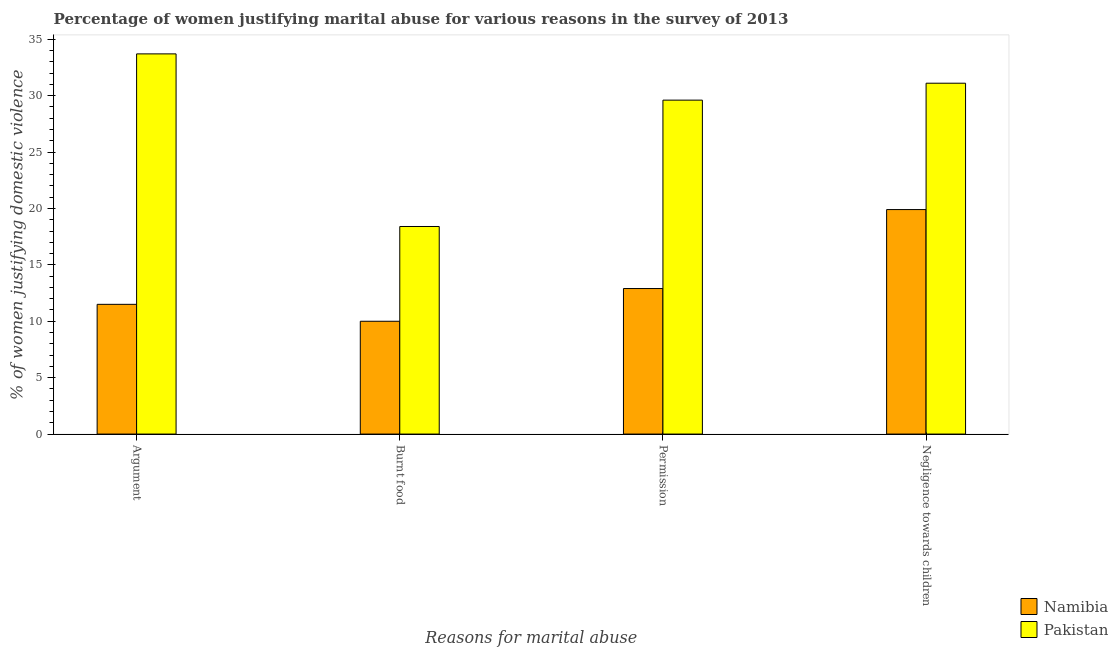How many different coloured bars are there?
Offer a terse response. 2. How many groups of bars are there?
Give a very brief answer. 4. How many bars are there on the 2nd tick from the right?
Your answer should be very brief. 2. What is the label of the 1st group of bars from the left?
Your answer should be compact. Argument. What is the percentage of women justifying abuse for burning food in Namibia?
Ensure brevity in your answer.  10. Across all countries, what is the maximum percentage of women justifying abuse for going without permission?
Your response must be concise. 29.6. Across all countries, what is the minimum percentage of women justifying abuse for burning food?
Offer a terse response. 10. In which country was the percentage of women justifying abuse for burning food maximum?
Ensure brevity in your answer.  Pakistan. In which country was the percentage of women justifying abuse in the case of an argument minimum?
Give a very brief answer. Namibia. What is the total percentage of women justifying abuse for burning food in the graph?
Offer a very short reply. 28.4. What is the difference between the percentage of women justifying abuse for showing negligence towards children in Namibia and that in Pakistan?
Provide a succinct answer. -11.2. What is the difference between the percentage of women justifying abuse for burning food in Namibia and the percentage of women justifying abuse in the case of an argument in Pakistan?
Keep it short and to the point. -23.7. What is the average percentage of women justifying abuse for showing negligence towards children per country?
Your answer should be compact. 25.5. What is the difference between the percentage of women justifying abuse in the case of an argument and percentage of women justifying abuse for going without permission in Pakistan?
Keep it short and to the point. 4.1. What is the ratio of the percentage of women justifying abuse for burning food in Pakistan to that in Namibia?
Give a very brief answer. 1.84. Is the difference between the percentage of women justifying abuse for going without permission in Pakistan and Namibia greater than the difference between the percentage of women justifying abuse for showing negligence towards children in Pakistan and Namibia?
Ensure brevity in your answer.  Yes. What is the difference between the highest and the second highest percentage of women justifying abuse for burning food?
Your answer should be compact. 8.4. What is the difference between the highest and the lowest percentage of women justifying abuse for going without permission?
Make the answer very short. 16.7. In how many countries, is the percentage of women justifying abuse in the case of an argument greater than the average percentage of women justifying abuse in the case of an argument taken over all countries?
Keep it short and to the point. 1. Is the sum of the percentage of women justifying abuse for going without permission in Pakistan and Namibia greater than the maximum percentage of women justifying abuse for showing negligence towards children across all countries?
Keep it short and to the point. Yes. What does the 1st bar from the left in Argument represents?
Give a very brief answer. Namibia. What does the 2nd bar from the right in Negligence towards children represents?
Your answer should be very brief. Namibia. Is it the case that in every country, the sum of the percentage of women justifying abuse in the case of an argument and percentage of women justifying abuse for burning food is greater than the percentage of women justifying abuse for going without permission?
Ensure brevity in your answer.  Yes. How many bars are there?
Make the answer very short. 8. How many countries are there in the graph?
Provide a succinct answer. 2. Does the graph contain any zero values?
Keep it short and to the point. No. Does the graph contain grids?
Give a very brief answer. No. Where does the legend appear in the graph?
Offer a terse response. Bottom right. What is the title of the graph?
Provide a succinct answer. Percentage of women justifying marital abuse for various reasons in the survey of 2013. What is the label or title of the X-axis?
Offer a terse response. Reasons for marital abuse. What is the label or title of the Y-axis?
Offer a very short reply. % of women justifying domestic violence. What is the % of women justifying domestic violence in Pakistan in Argument?
Give a very brief answer. 33.7. What is the % of women justifying domestic violence of Namibia in Burnt food?
Your answer should be very brief. 10. What is the % of women justifying domestic violence of Pakistan in Burnt food?
Provide a succinct answer. 18.4. What is the % of women justifying domestic violence in Namibia in Permission?
Your response must be concise. 12.9. What is the % of women justifying domestic violence of Pakistan in Permission?
Make the answer very short. 29.6. What is the % of women justifying domestic violence of Namibia in Negligence towards children?
Provide a succinct answer. 19.9. What is the % of women justifying domestic violence of Pakistan in Negligence towards children?
Ensure brevity in your answer.  31.1. Across all Reasons for marital abuse, what is the maximum % of women justifying domestic violence in Pakistan?
Offer a very short reply. 33.7. Across all Reasons for marital abuse, what is the minimum % of women justifying domestic violence in Namibia?
Provide a succinct answer. 10. Across all Reasons for marital abuse, what is the minimum % of women justifying domestic violence in Pakistan?
Provide a succinct answer. 18.4. What is the total % of women justifying domestic violence in Namibia in the graph?
Ensure brevity in your answer.  54.3. What is the total % of women justifying domestic violence in Pakistan in the graph?
Offer a very short reply. 112.8. What is the difference between the % of women justifying domestic violence of Namibia in Argument and that in Permission?
Keep it short and to the point. -1.4. What is the difference between the % of women justifying domestic violence of Pakistan in Argument and that in Permission?
Offer a very short reply. 4.1. What is the difference between the % of women justifying domestic violence in Namibia in Argument and that in Negligence towards children?
Offer a terse response. -8.4. What is the difference between the % of women justifying domestic violence of Namibia in Burnt food and that in Permission?
Your answer should be very brief. -2.9. What is the difference between the % of women justifying domestic violence in Pakistan in Burnt food and that in Permission?
Ensure brevity in your answer.  -11.2. What is the difference between the % of women justifying domestic violence of Namibia in Burnt food and that in Negligence towards children?
Offer a very short reply. -9.9. What is the difference between the % of women justifying domestic violence of Pakistan in Burnt food and that in Negligence towards children?
Your answer should be very brief. -12.7. What is the difference between the % of women justifying domestic violence of Namibia in Permission and that in Negligence towards children?
Your response must be concise. -7. What is the difference between the % of women justifying domestic violence in Namibia in Argument and the % of women justifying domestic violence in Pakistan in Burnt food?
Ensure brevity in your answer.  -6.9. What is the difference between the % of women justifying domestic violence of Namibia in Argument and the % of women justifying domestic violence of Pakistan in Permission?
Keep it short and to the point. -18.1. What is the difference between the % of women justifying domestic violence of Namibia in Argument and the % of women justifying domestic violence of Pakistan in Negligence towards children?
Your answer should be very brief. -19.6. What is the difference between the % of women justifying domestic violence of Namibia in Burnt food and the % of women justifying domestic violence of Pakistan in Permission?
Provide a succinct answer. -19.6. What is the difference between the % of women justifying domestic violence in Namibia in Burnt food and the % of women justifying domestic violence in Pakistan in Negligence towards children?
Offer a terse response. -21.1. What is the difference between the % of women justifying domestic violence in Namibia in Permission and the % of women justifying domestic violence in Pakistan in Negligence towards children?
Your answer should be compact. -18.2. What is the average % of women justifying domestic violence of Namibia per Reasons for marital abuse?
Ensure brevity in your answer.  13.57. What is the average % of women justifying domestic violence in Pakistan per Reasons for marital abuse?
Make the answer very short. 28.2. What is the difference between the % of women justifying domestic violence of Namibia and % of women justifying domestic violence of Pakistan in Argument?
Ensure brevity in your answer.  -22.2. What is the difference between the % of women justifying domestic violence in Namibia and % of women justifying domestic violence in Pakistan in Burnt food?
Ensure brevity in your answer.  -8.4. What is the difference between the % of women justifying domestic violence of Namibia and % of women justifying domestic violence of Pakistan in Permission?
Your answer should be compact. -16.7. What is the difference between the % of women justifying domestic violence in Namibia and % of women justifying domestic violence in Pakistan in Negligence towards children?
Make the answer very short. -11.2. What is the ratio of the % of women justifying domestic violence of Namibia in Argument to that in Burnt food?
Provide a succinct answer. 1.15. What is the ratio of the % of women justifying domestic violence of Pakistan in Argument to that in Burnt food?
Offer a terse response. 1.83. What is the ratio of the % of women justifying domestic violence of Namibia in Argument to that in Permission?
Offer a terse response. 0.89. What is the ratio of the % of women justifying domestic violence of Pakistan in Argument to that in Permission?
Keep it short and to the point. 1.14. What is the ratio of the % of women justifying domestic violence in Namibia in Argument to that in Negligence towards children?
Your answer should be compact. 0.58. What is the ratio of the % of women justifying domestic violence of Pakistan in Argument to that in Negligence towards children?
Offer a terse response. 1.08. What is the ratio of the % of women justifying domestic violence of Namibia in Burnt food to that in Permission?
Make the answer very short. 0.78. What is the ratio of the % of women justifying domestic violence of Pakistan in Burnt food to that in Permission?
Your answer should be compact. 0.62. What is the ratio of the % of women justifying domestic violence of Namibia in Burnt food to that in Negligence towards children?
Provide a succinct answer. 0.5. What is the ratio of the % of women justifying domestic violence of Pakistan in Burnt food to that in Negligence towards children?
Offer a very short reply. 0.59. What is the ratio of the % of women justifying domestic violence of Namibia in Permission to that in Negligence towards children?
Your answer should be very brief. 0.65. What is the ratio of the % of women justifying domestic violence of Pakistan in Permission to that in Negligence towards children?
Offer a terse response. 0.95. What is the difference between the highest and the second highest % of women justifying domestic violence of Namibia?
Make the answer very short. 7. What is the difference between the highest and the second highest % of women justifying domestic violence of Pakistan?
Offer a very short reply. 2.6. What is the difference between the highest and the lowest % of women justifying domestic violence in Pakistan?
Make the answer very short. 15.3. 